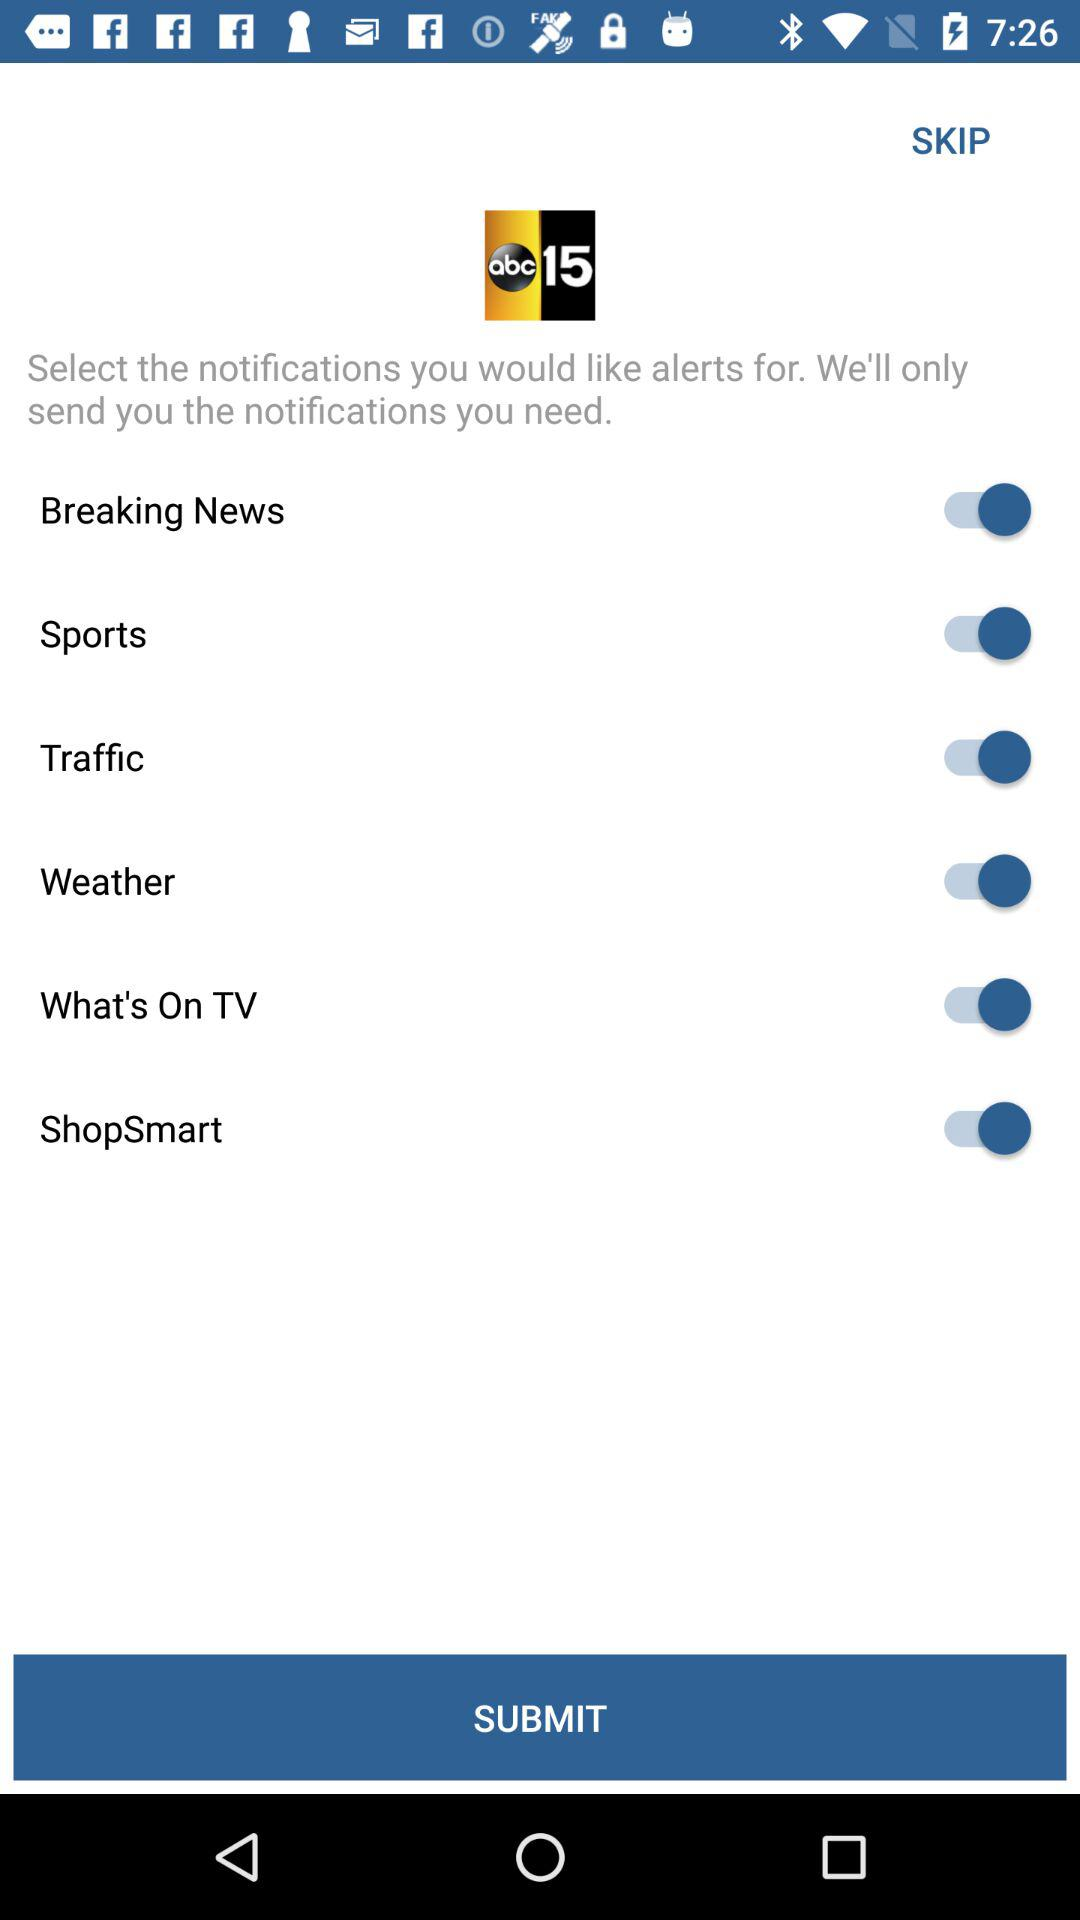How many notification types are available?
Answer the question using a single word or phrase. 6 